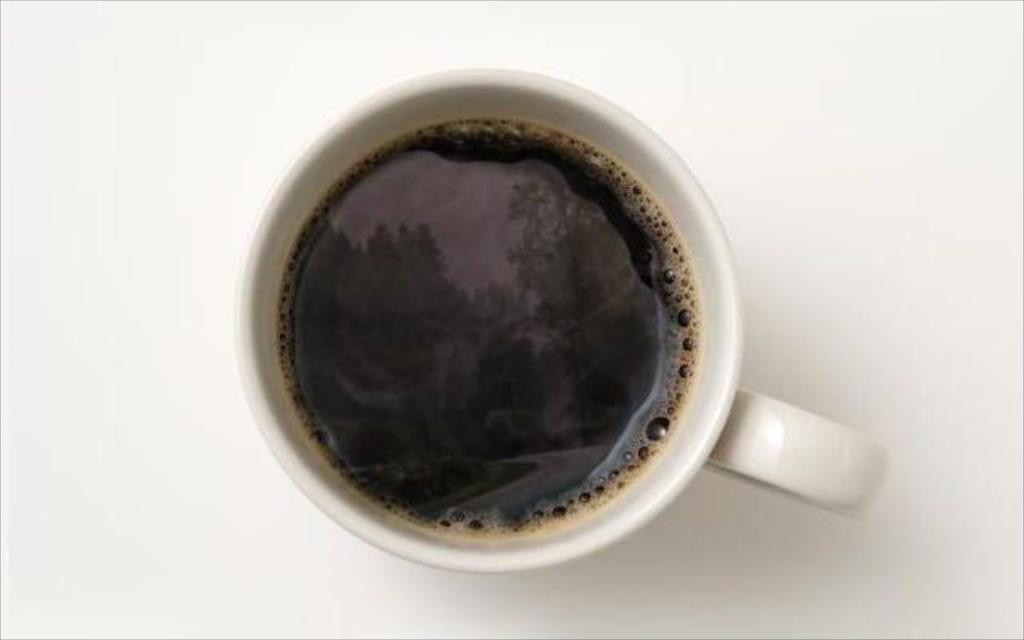What is in the cup that is visible in the image? There is a cup of coffee in the image. Where is the cup of coffee located? The cup of coffee is placed on a table. What type of control panel can be seen in the image? There is no control panel present in the image; it only features a cup of coffee on a table. 